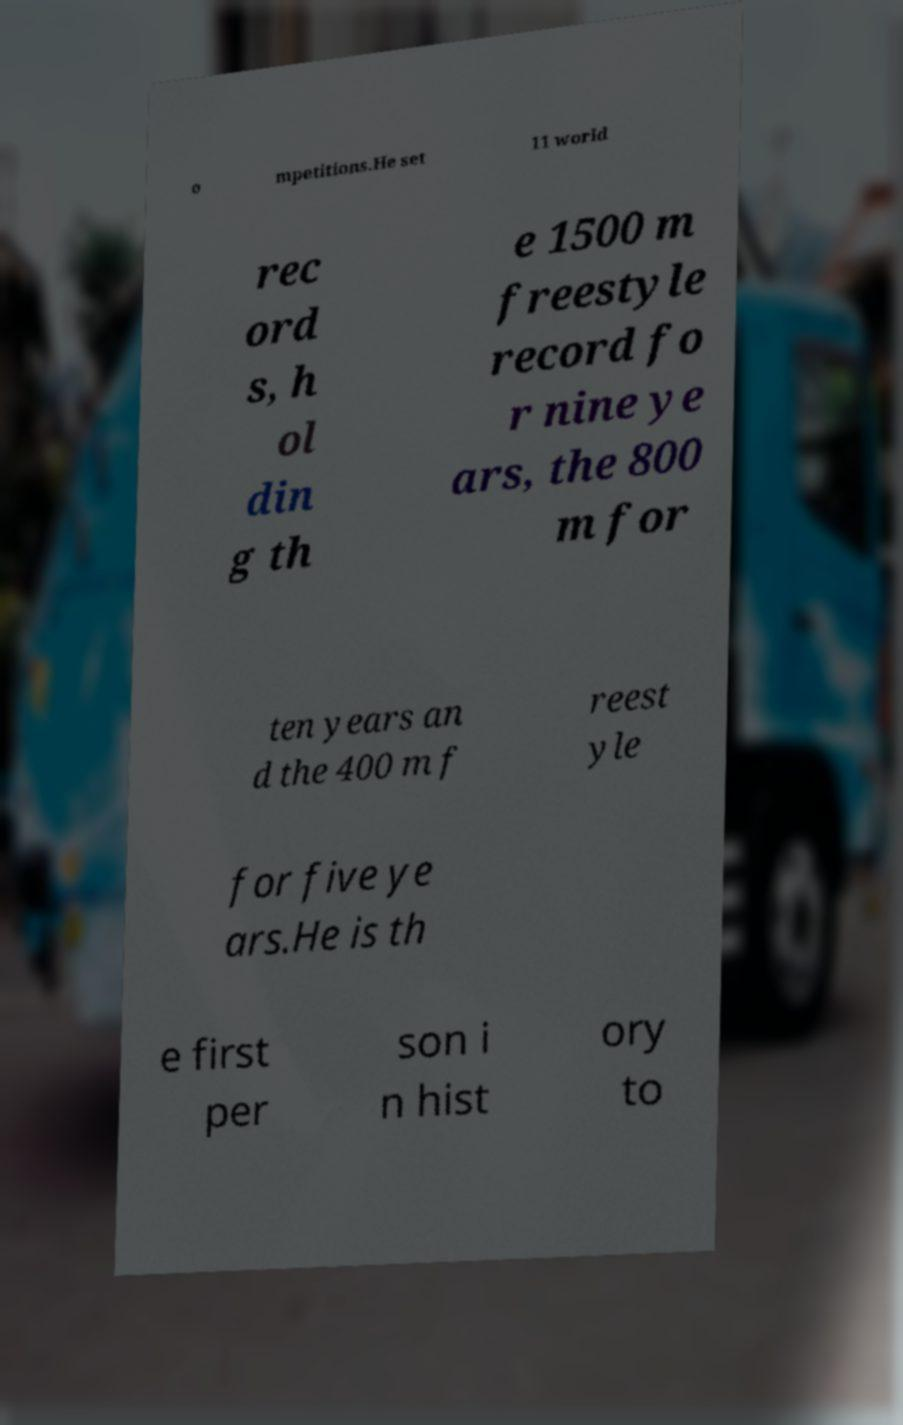Please identify and transcribe the text found in this image. o mpetitions.He set 11 world rec ord s, h ol din g th e 1500 m freestyle record fo r nine ye ars, the 800 m for ten years an d the 400 m f reest yle for five ye ars.He is th e first per son i n hist ory to 